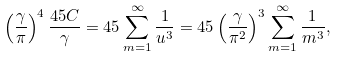Convert formula to latex. <formula><loc_0><loc_0><loc_500><loc_500>\left ( \frac { \gamma } { \pi } \right ) ^ { 4 } \frac { 4 5 C } { \gamma } = 4 5 \sum _ { m = 1 } ^ { \infty } \frac { 1 } { u ^ { 3 } } = 4 5 \left ( \frac { \gamma } { \pi ^ { 2 } } \right ) ^ { 3 } \sum _ { m = 1 } ^ { \infty } \frac { 1 } { m ^ { 3 } } ,</formula> 